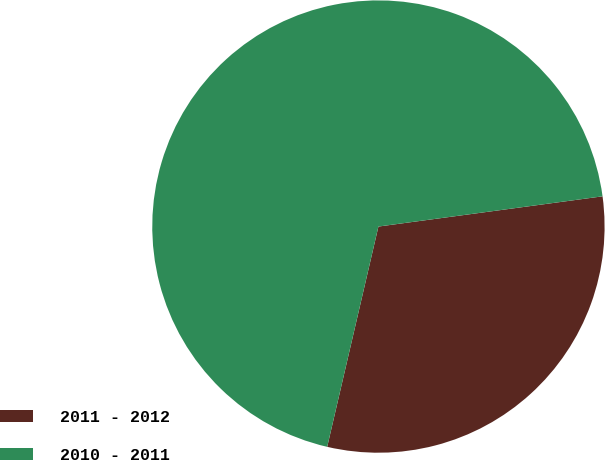Convert chart to OTSL. <chart><loc_0><loc_0><loc_500><loc_500><pie_chart><fcel>2011 - 2012<fcel>2010 - 2011<nl><fcel>30.77%<fcel>69.23%<nl></chart> 